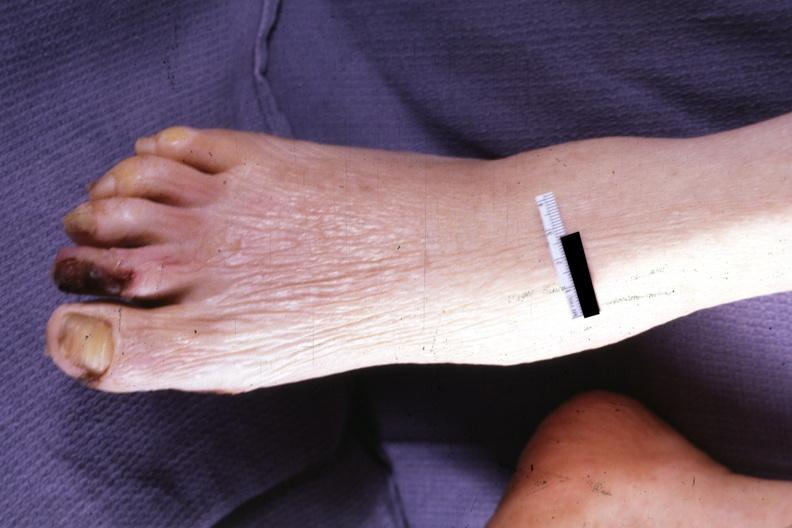s gangrene present?
Answer the question using a single word or phrase. Yes 